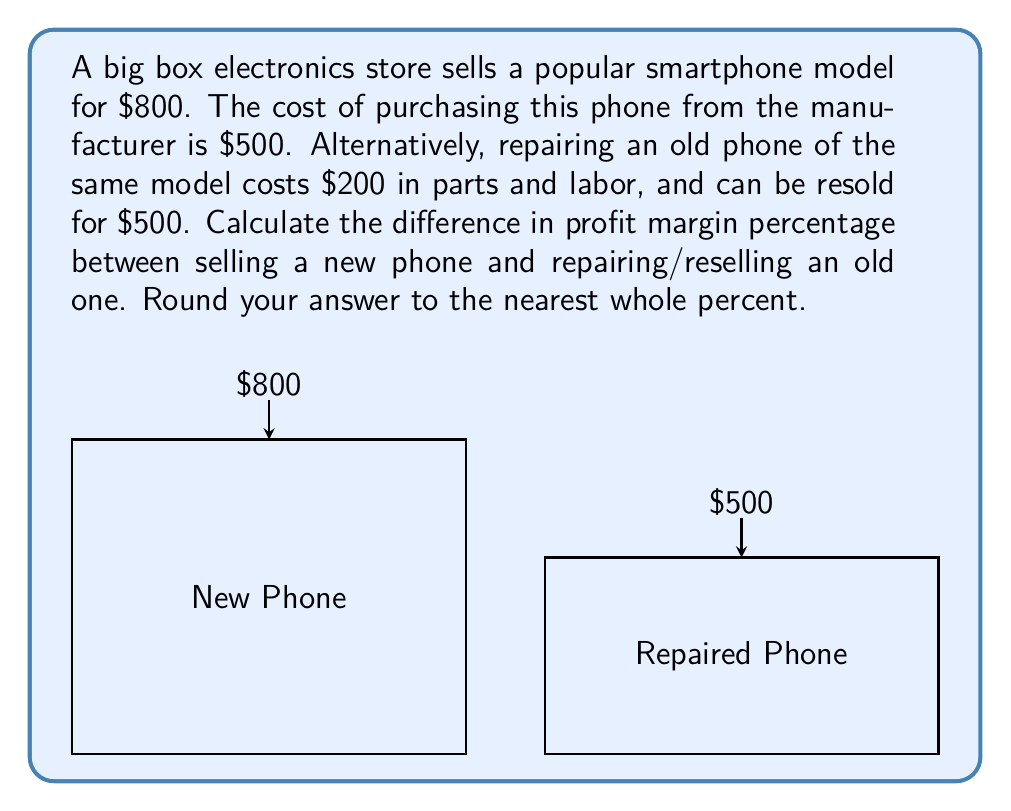Could you help me with this problem? Let's approach this step-by-step:

1) For the new phone:
   - Selling price: $800
   - Cost: $500
   - Profit: $800 - $500 = $300
   - Profit margin = $\frac{\text{Profit}}{\text{Selling Price}} \times 100\%$
   - Profit margin = $\frac{300}{800} \times 100\% = 37.5\%$

2) For the repaired phone:
   - Selling price: $500
   - Cost (repair): $200
   - Profit: $500 - $200 = $300
   - Profit margin = $\frac{300}{500} \times 100\% = 60\%$

3) Difference in profit margin:
   $60\% - 37.5\% = 22.5\%$

4) Rounding to the nearest whole percent:
   $22.5\%$ rounds to $23\%$

Therefore, the difference in profit margin percentage between repairing/reselling an old phone and selling a new phone is 23% in favor of repairing/reselling.
Answer: 23% 